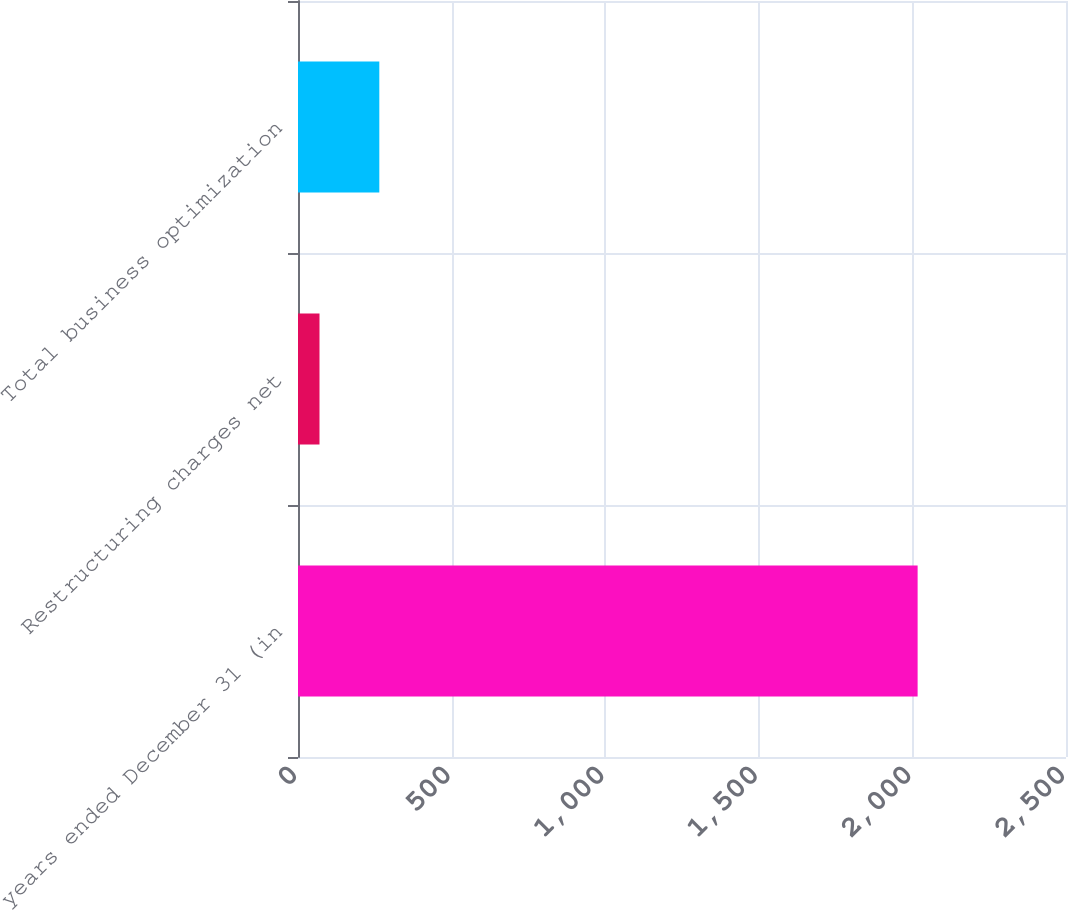Convert chart. <chart><loc_0><loc_0><loc_500><loc_500><bar_chart><fcel>years ended December 31 (in<fcel>Restructuring charges net<fcel>Total business optimization<nl><fcel>2017<fcel>70<fcel>264.7<nl></chart> 